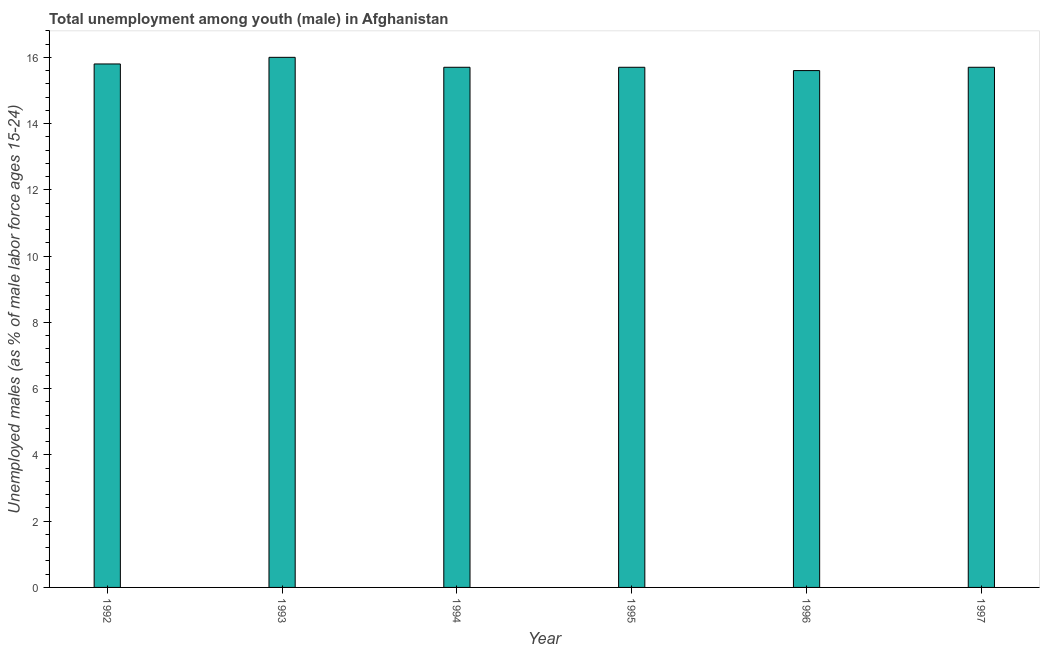Does the graph contain any zero values?
Make the answer very short. No. Does the graph contain grids?
Offer a terse response. No. What is the title of the graph?
Provide a succinct answer. Total unemployment among youth (male) in Afghanistan. What is the label or title of the Y-axis?
Provide a short and direct response. Unemployed males (as % of male labor force ages 15-24). What is the unemployed male youth population in 1993?
Give a very brief answer. 16. Across all years, what is the minimum unemployed male youth population?
Your answer should be very brief. 15.6. In which year was the unemployed male youth population minimum?
Offer a terse response. 1996. What is the sum of the unemployed male youth population?
Keep it short and to the point. 94.5. What is the difference between the unemployed male youth population in 1994 and 1995?
Your response must be concise. 0. What is the average unemployed male youth population per year?
Offer a terse response. 15.75. What is the median unemployed male youth population?
Make the answer very short. 15.7. In how many years, is the unemployed male youth population greater than 9.2 %?
Keep it short and to the point. 6. Do a majority of the years between 1995 and 1994 (inclusive) have unemployed male youth population greater than 16.4 %?
Ensure brevity in your answer.  No. What is the ratio of the unemployed male youth population in 1993 to that in 1997?
Provide a short and direct response. 1.02. What is the difference between the highest and the second highest unemployed male youth population?
Your answer should be compact. 0.2. Is the sum of the unemployed male youth population in 1996 and 1997 greater than the maximum unemployed male youth population across all years?
Make the answer very short. Yes. What is the difference between the highest and the lowest unemployed male youth population?
Your response must be concise. 0.4. In how many years, is the unemployed male youth population greater than the average unemployed male youth population taken over all years?
Provide a short and direct response. 2. How many bars are there?
Your response must be concise. 6. Are the values on the major ticks of Y-axis written in scientific E-notation?
Your answer should be very brief. No. What is the Unemployed males (as % of male labor force ages 15-24) in 1992?
Provide a succinct answer. 15.8. What is the Unemployed males (as % of male labor force ages 15-24) in 1994?
Give a very brief answer. 15.7. What is the Unemployed males (as % of male labor force ages 15-24) in 1995?
Offer a very short reply. 15.7. What is the Unemployed males (as % of male labor force ages 15-24) of 1996?
Make the answer very short. 15.6. What is the Unemployed males (as % of male labor force ages 15-24) of 1997?
Provide a succinct answer. 15.7. What is the difference between the Unemployed males (as % of male labor force ages 15-24) in 1992 and 1993?
Give a very brief answer. -0.2. What is the difference between the Unemployed males (as % of male labor force ages 15-24) in 1992 and 1994?
Your response must be concise. 0.1. What is the difference between the Unemployed males (as % of male labor force ages 15-24) in 1992 and 1995?
Ensure brevity in your answer.  0.1. What is the difference between the Unemployed males (as % of male labor force ages 15-24) in 1992 and 1996?
Your answer should be compact. 0.2. What is the difference between the Unemployed males (as % of male labor force ages 15-24) in 1992 and 1997?
Ensure brevity in your answer.  0.1. What is the difference between the Unemployed males (as % of male labor force ages 15-24) in 1993 and 1995?
Offer a terse response. 0.3. What is the difference between the Unemployed males (as % of male labor force ages 15-24) in 1994 and 1996?
Make the answer very short. 0.1. What is the ratio of the Unemployed males (as % of male labor force ages 15-24) in 1992 to that in 1993?
Offer a very short reply. 0.99. What is the ratio of the Unemployed males (as % of male labor force ages 15-24) in 1992 to that in 1997?
Your response must be concise. 1.01. What is the ratio of the Unemployed males (as % of male labor force ages 15-24) in 1993 to that in 1996?
Your answer should be compact. 1.03. What is the ratio of the Unemployed males (as % of male labor force ages 15-24) in 1994 to that in 1996?
Ensure brevity in your answer.  1.01. What is the ratio of the Unemployed males (as % of male labor force ages 15-24) in 1995 to that in 1996?
Offer a terse response. 1.01. What is the ratio of the Unemployed males (as % of male labor force ages 15-24) in 1995 to that in 1997?
Ensure brevity in your answer.  1. What is the ratio of the Unemployed males (as % of male labor force ages 15-24) in 1996 to that in 1997?
Offer a very short reply. 0.99. 